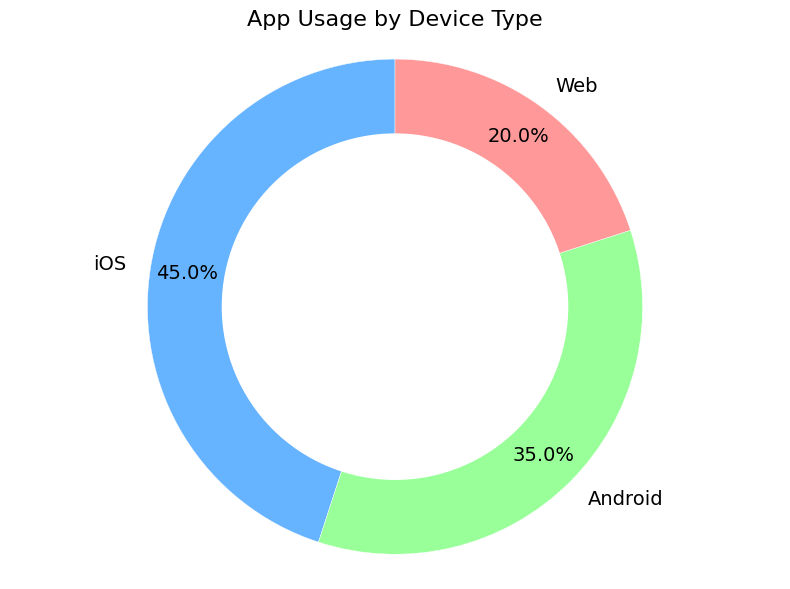What percentage of app usage does iOS account for? The pie chart shows that iOS accounts for 45% of app usage, depicted by the segment labeled 'iOS'.
Answer: 45% What is the most used device type for accessing the app? To determine the most used device type, we compare the percentages. iOS has 45%, Android has 35%, and Web has 20%. iOS has the highest percentage.
Answer: iOS What is the combined percentage of app usage for Android and Web? To find the combined percentage, we add the usage percentages for Android and Web: 35% + 20% = 55%.
Answer: 55% How much more app usage does iOS have compared to Web? To find the difference in app usage between iOS and Web, we subtract Web's percentage from iOS's percentage: 45% - 20% = 25%.
Answer: 25% Which device type has the least app usage? By comparing the given percentages, Web has the smallest percentage at 20%.
Answer: Web Is Android usage more than half of iOS usage? Half of iOS usage is 45% / 2 = 22.5%. Comparing this to Android's usage of 35%, 35% is indeed greater than 22.5%.
Answer: Yes What percentage of app usage is not iOS? To find the non-iOS usage, we subtract iOS's percentage from 100%: 100% - 45% = 55%.
Answer: 55% How much greater is the combined usage of iOS and Android compared to Web? First, sum the usage of iOS and Android: 45% + 35% = 80%. Then, subtract Web's usage from this total: 80% - 20% = 60%.
Answer: 60% Rank the device types from most to least used. According to their usage percentages, the ranking is: iOS (45%), Android (35%), Web (20%).
Answer: iOS, Android, Web What color represents Android usage in the pie chart? From the pie chart, Android is represented by the green segment.
Answer: Green 